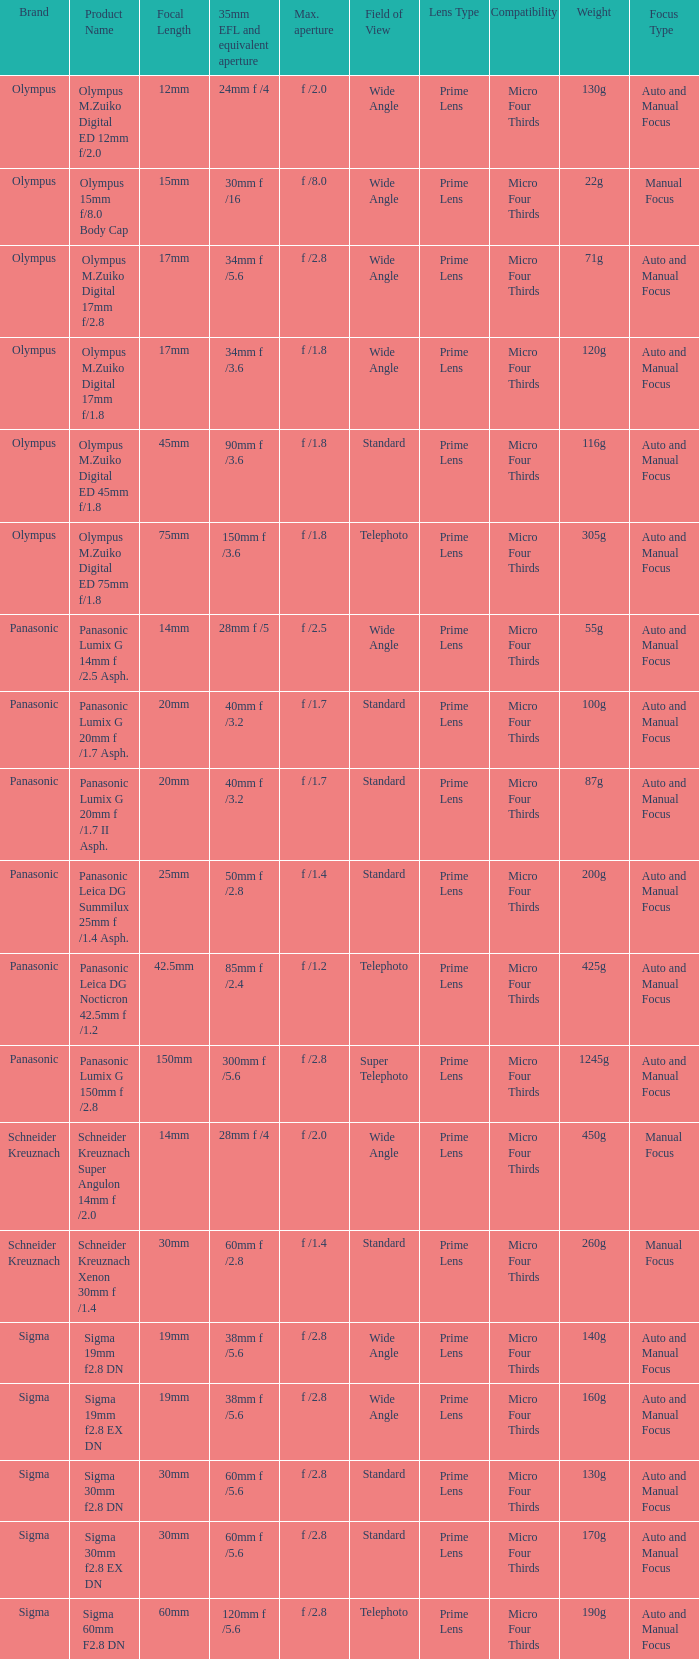What is the brand of the Sigma 30mm f2.8 DN, which has a maximum aperture of f /2.8 and a focal length of 30mm? Sigma. 